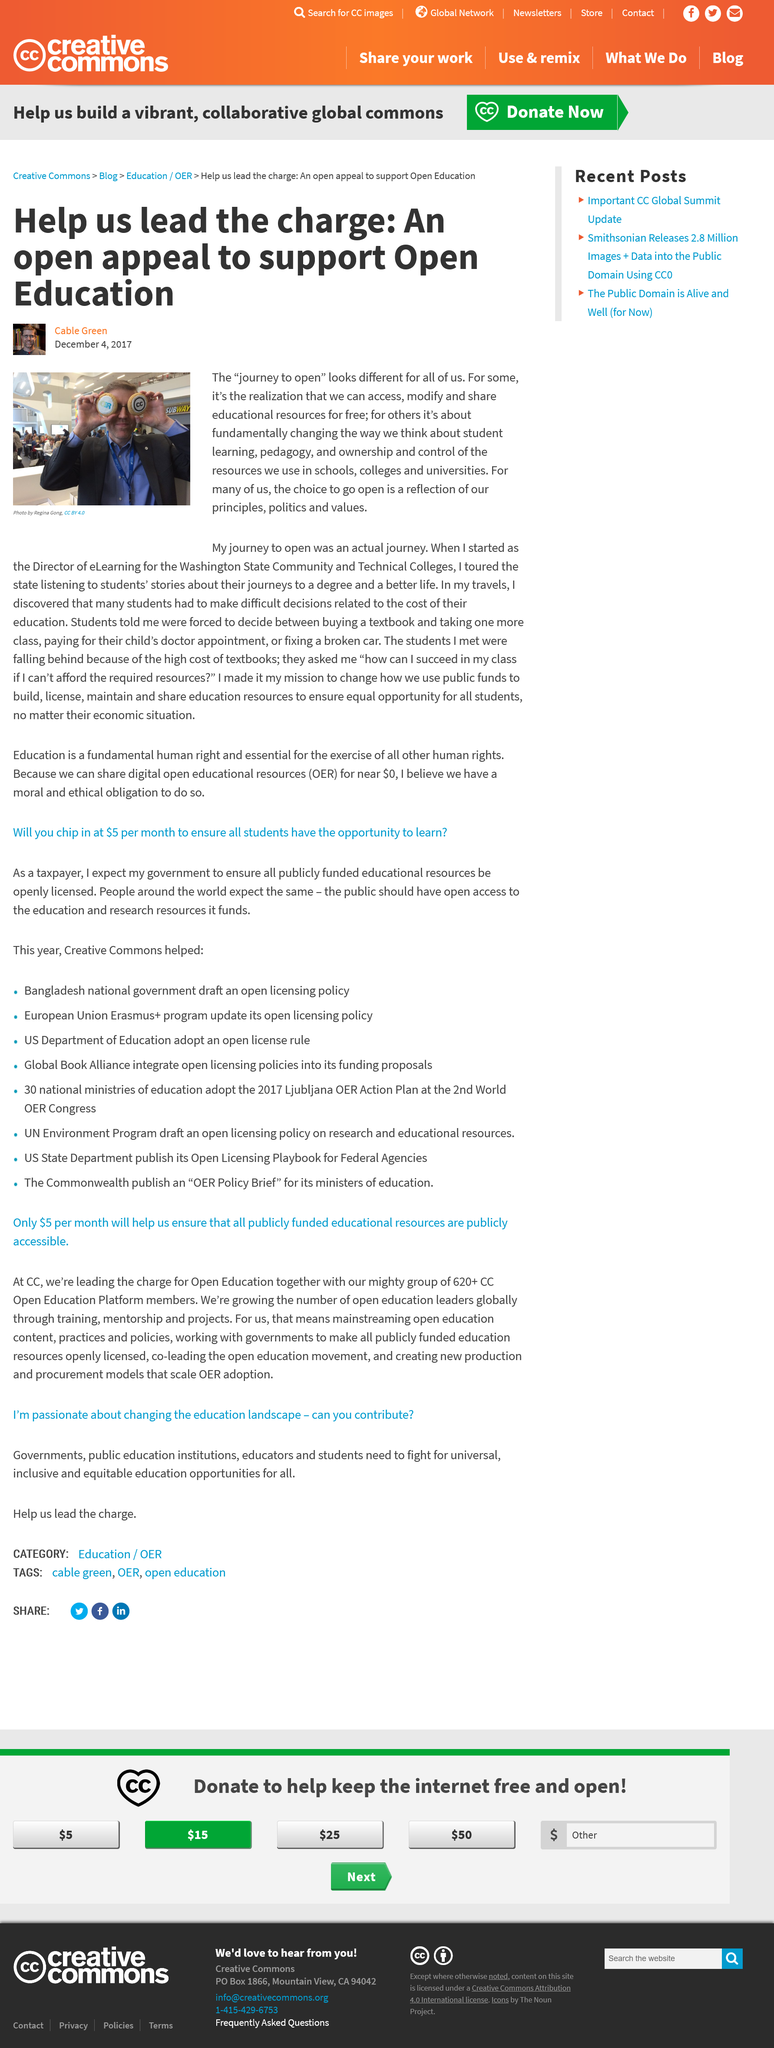Specify some key components in this picture. There are at least 620 CC Open Education Platform members. Access to educational resources for free would significantly change student learning and pedagogy. The author of this article hopes to appeal to the public and encourage support for Open Education. The number of open education leaders globally is increasing through training, mentorship, and projects. The leaders of the "open education" movement are requesting a monthly contribution of $5 from individuals in order to ensure that all publicly funded educational resources are publicly accessible. 